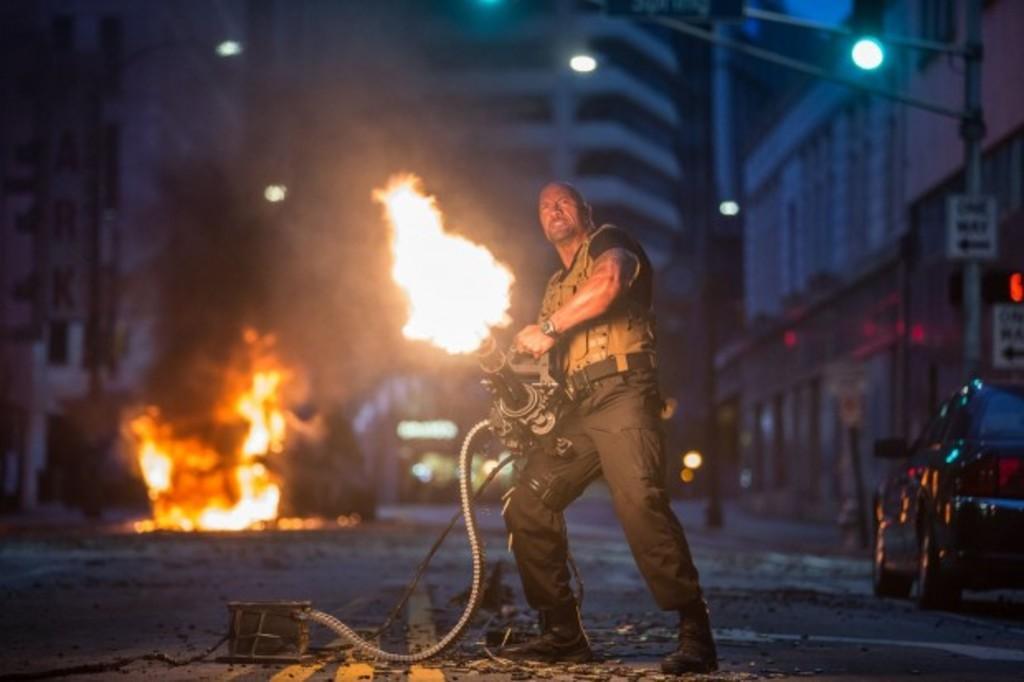Can you describe this image briefly? In the image we can see a man standing, wearing clothes, a wrist watch and the man is holding an object in hands. This is a flame, pipe, road, vehicle on the road, pole, light and buildings. 